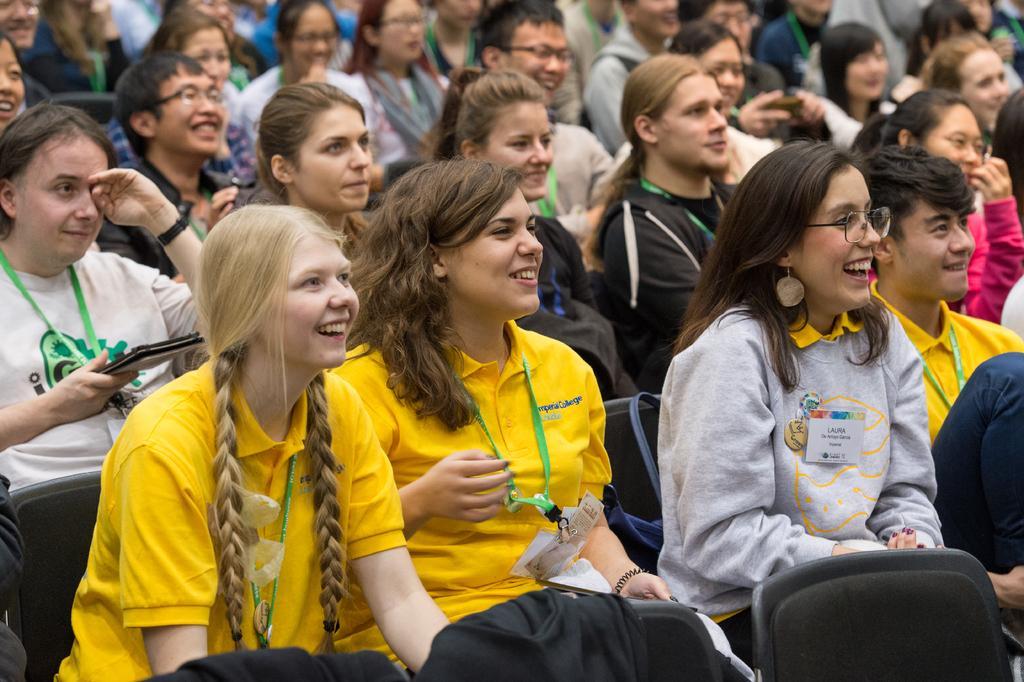Please provide a concise description of this image. In this image I can see people are sitting on chairs. Among them some are wearing ID cards and spectacles. Some of them are also smiling. 